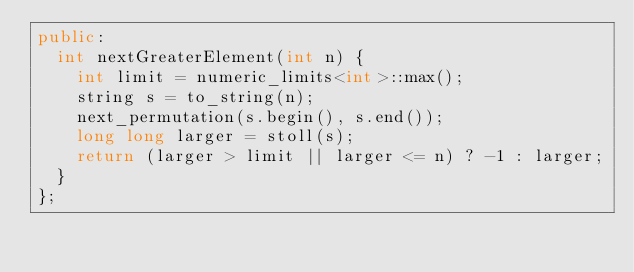Convert code to text. <code><loc_0><loc_0><loc_500><loc_500><_C++_>public:
	int nextGreaterElement(int n) {
		int limit = numeric_limits<int>::max();
		string s = to_string(n);
		next_permutation(s.begin(), s.end());
		long long larger = stoll(s);
		return (larger > limit || larger <= n) ? -1 : larger;
	}
};</code> 